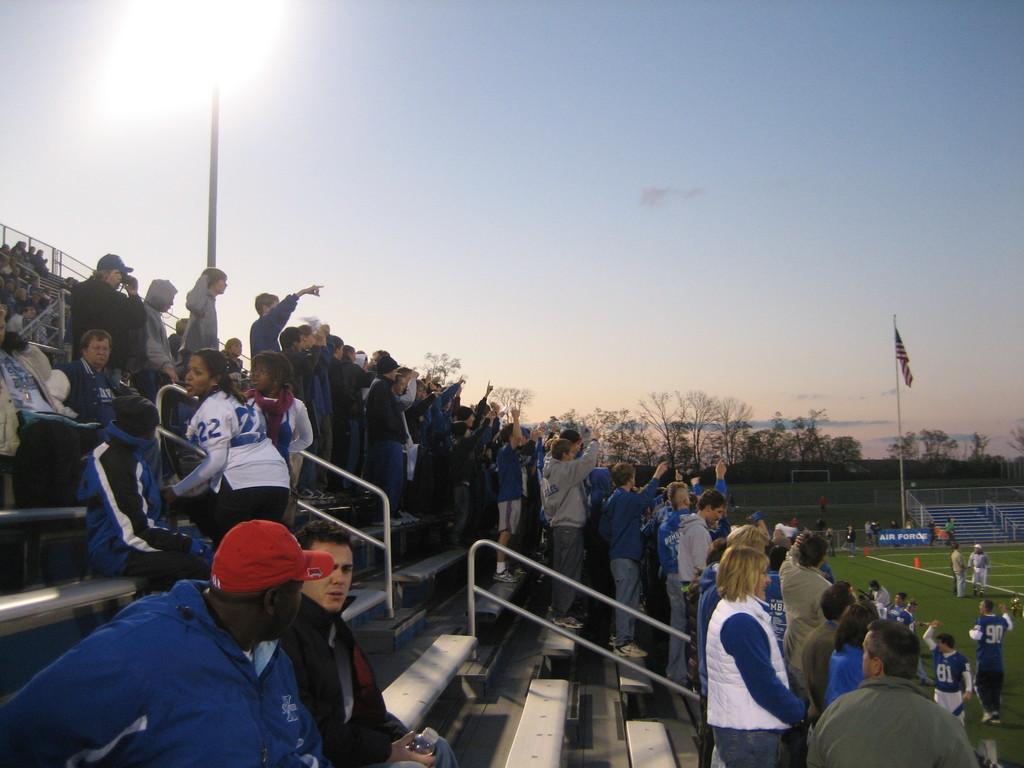How would you summarize this image in a sentence or two? In this image we can see people sitting and standing on the staircase, people standing on the ground, flag to the flag post, railings, trees and sky. 